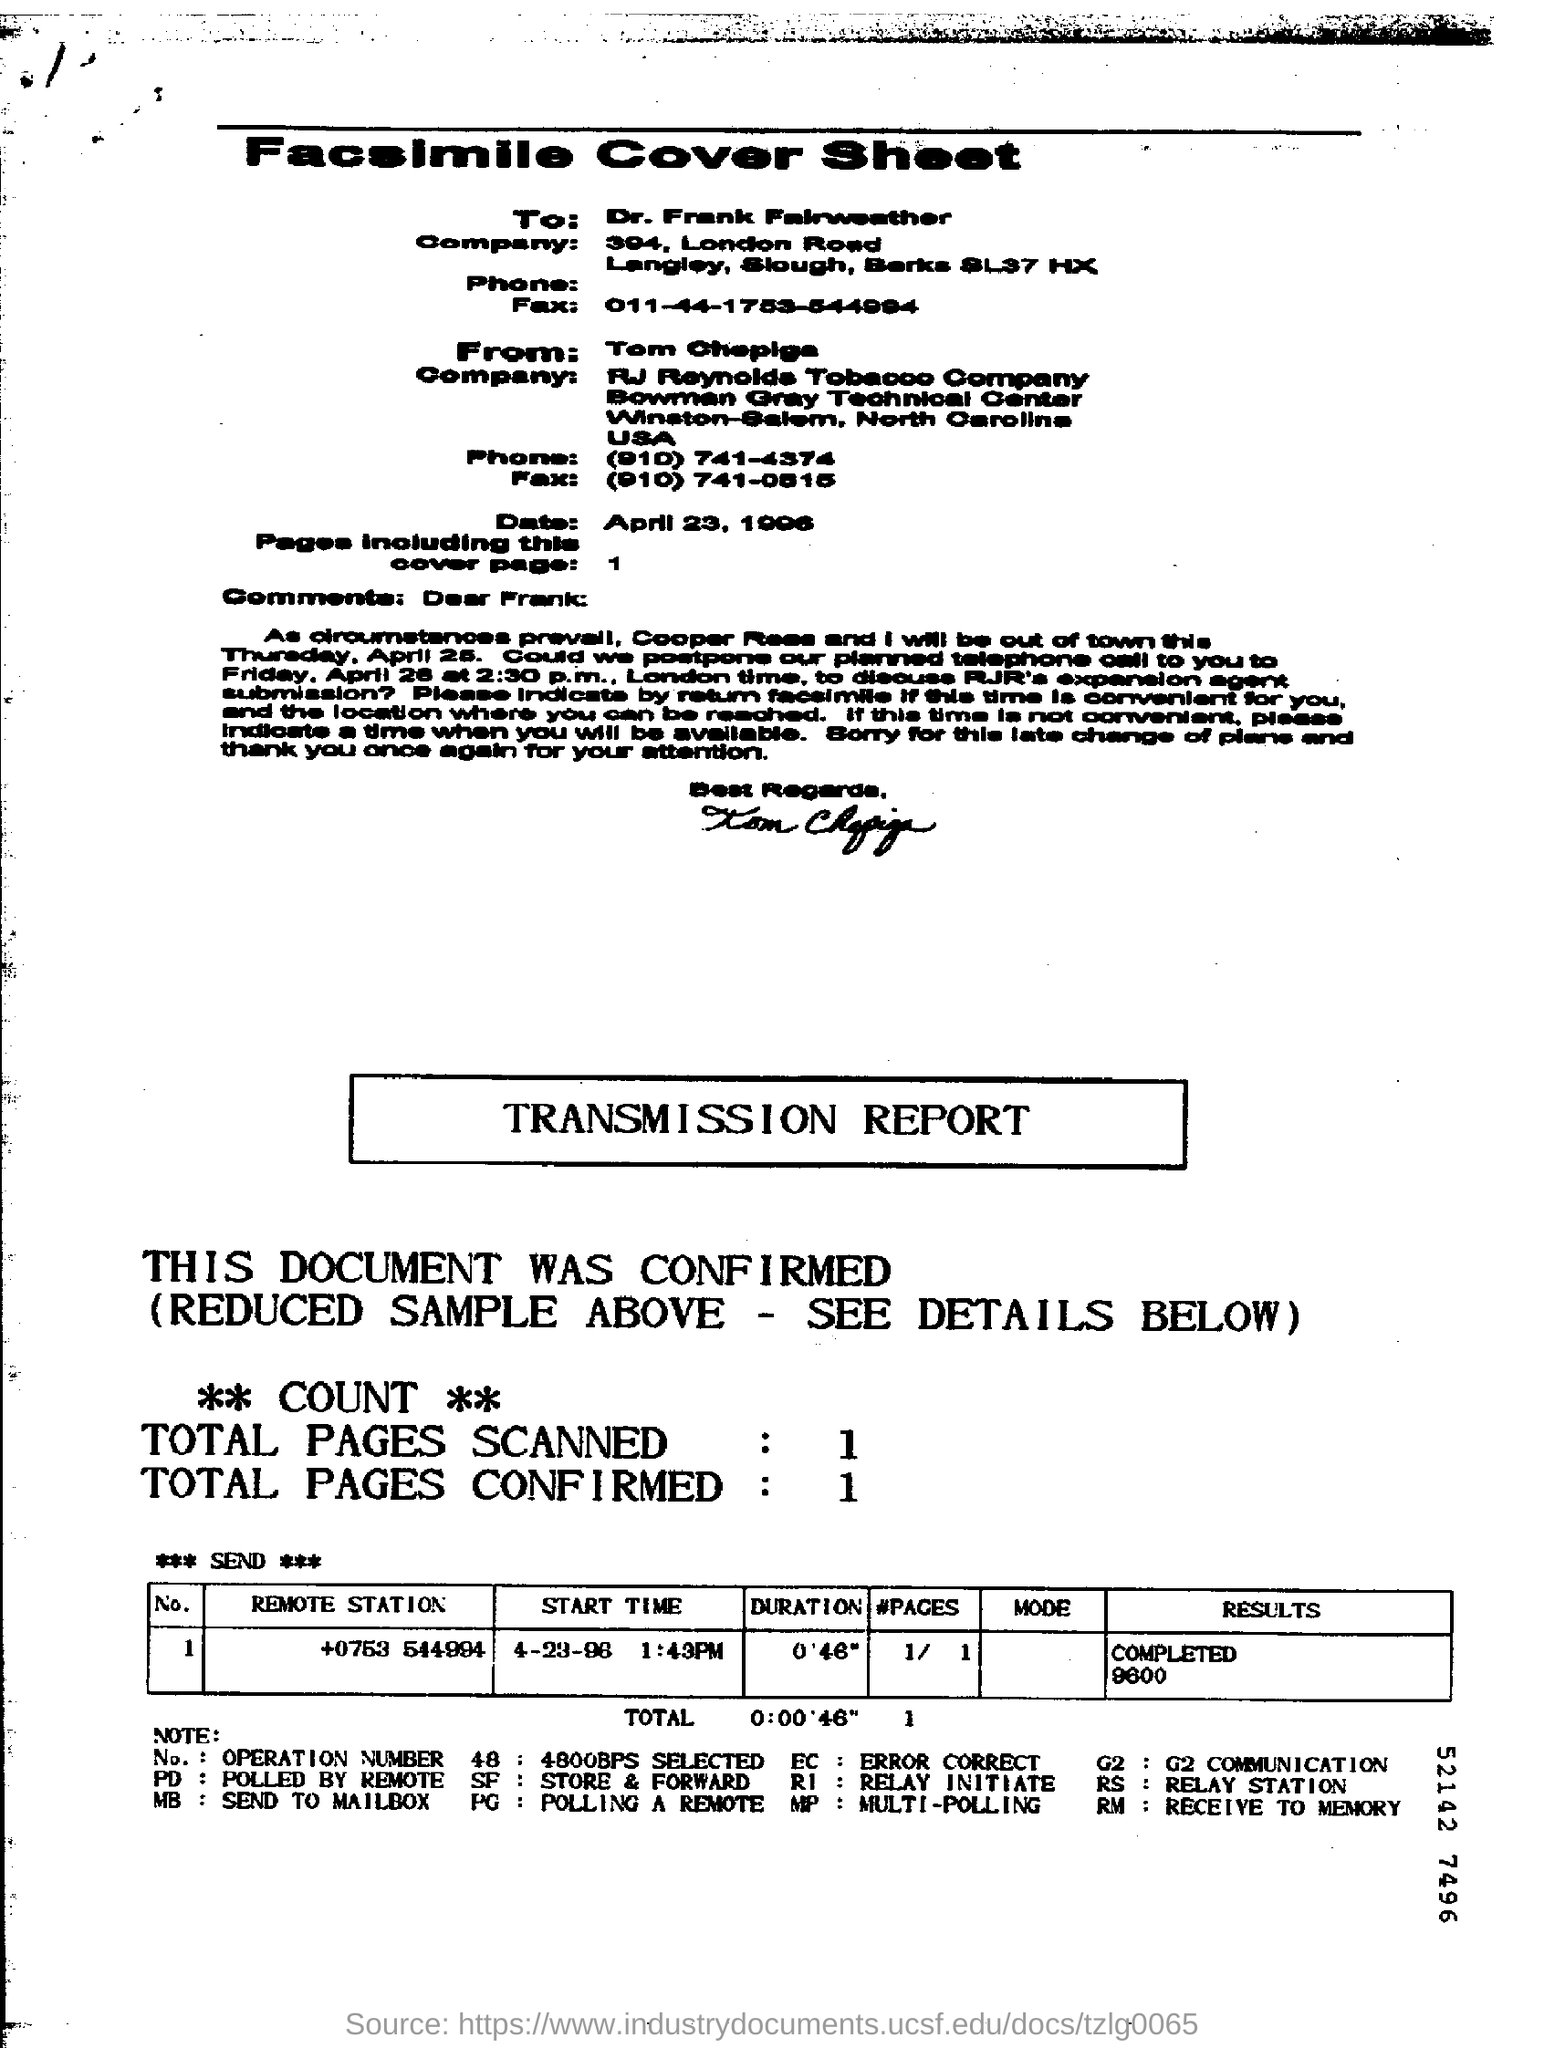Point out several critical features in this image. The remote station number is 0753544994. The fax number of Dr. Frank Fairweather is 011-44-1753-544994. The notation RM denotes the act of receiving data to be stored in memory. The fax is addressed to Dr. Frank Fairweather. 